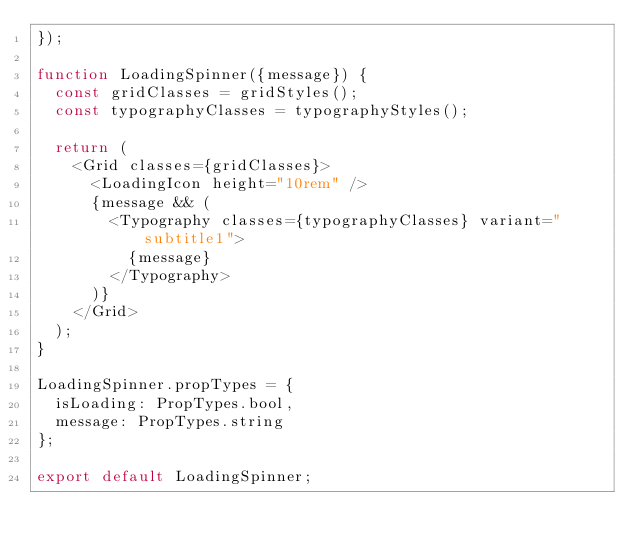<code> <loc_0><loc_0><loc_500><loc_500><_JavaScript_>});

function LoadingSpinner({message}) {
  const gridClasses = gridStyles();
  const typographyClasses = typographyStyles();

  return (
    <Grid classes={gridClasses}>
      <LoadingIcon height="10rem" />
      {message && (
        <Typography classes={typographyClasses} variant="subtitle1">
          {message}
        </Typography>
      )}
    </Grid>
  );
}

LoadingSpinner.propTypes = {
  isLoading: PropTypes.bool,
  message: PropTypes.string
};

export default LoadingSpinner;
</code> 